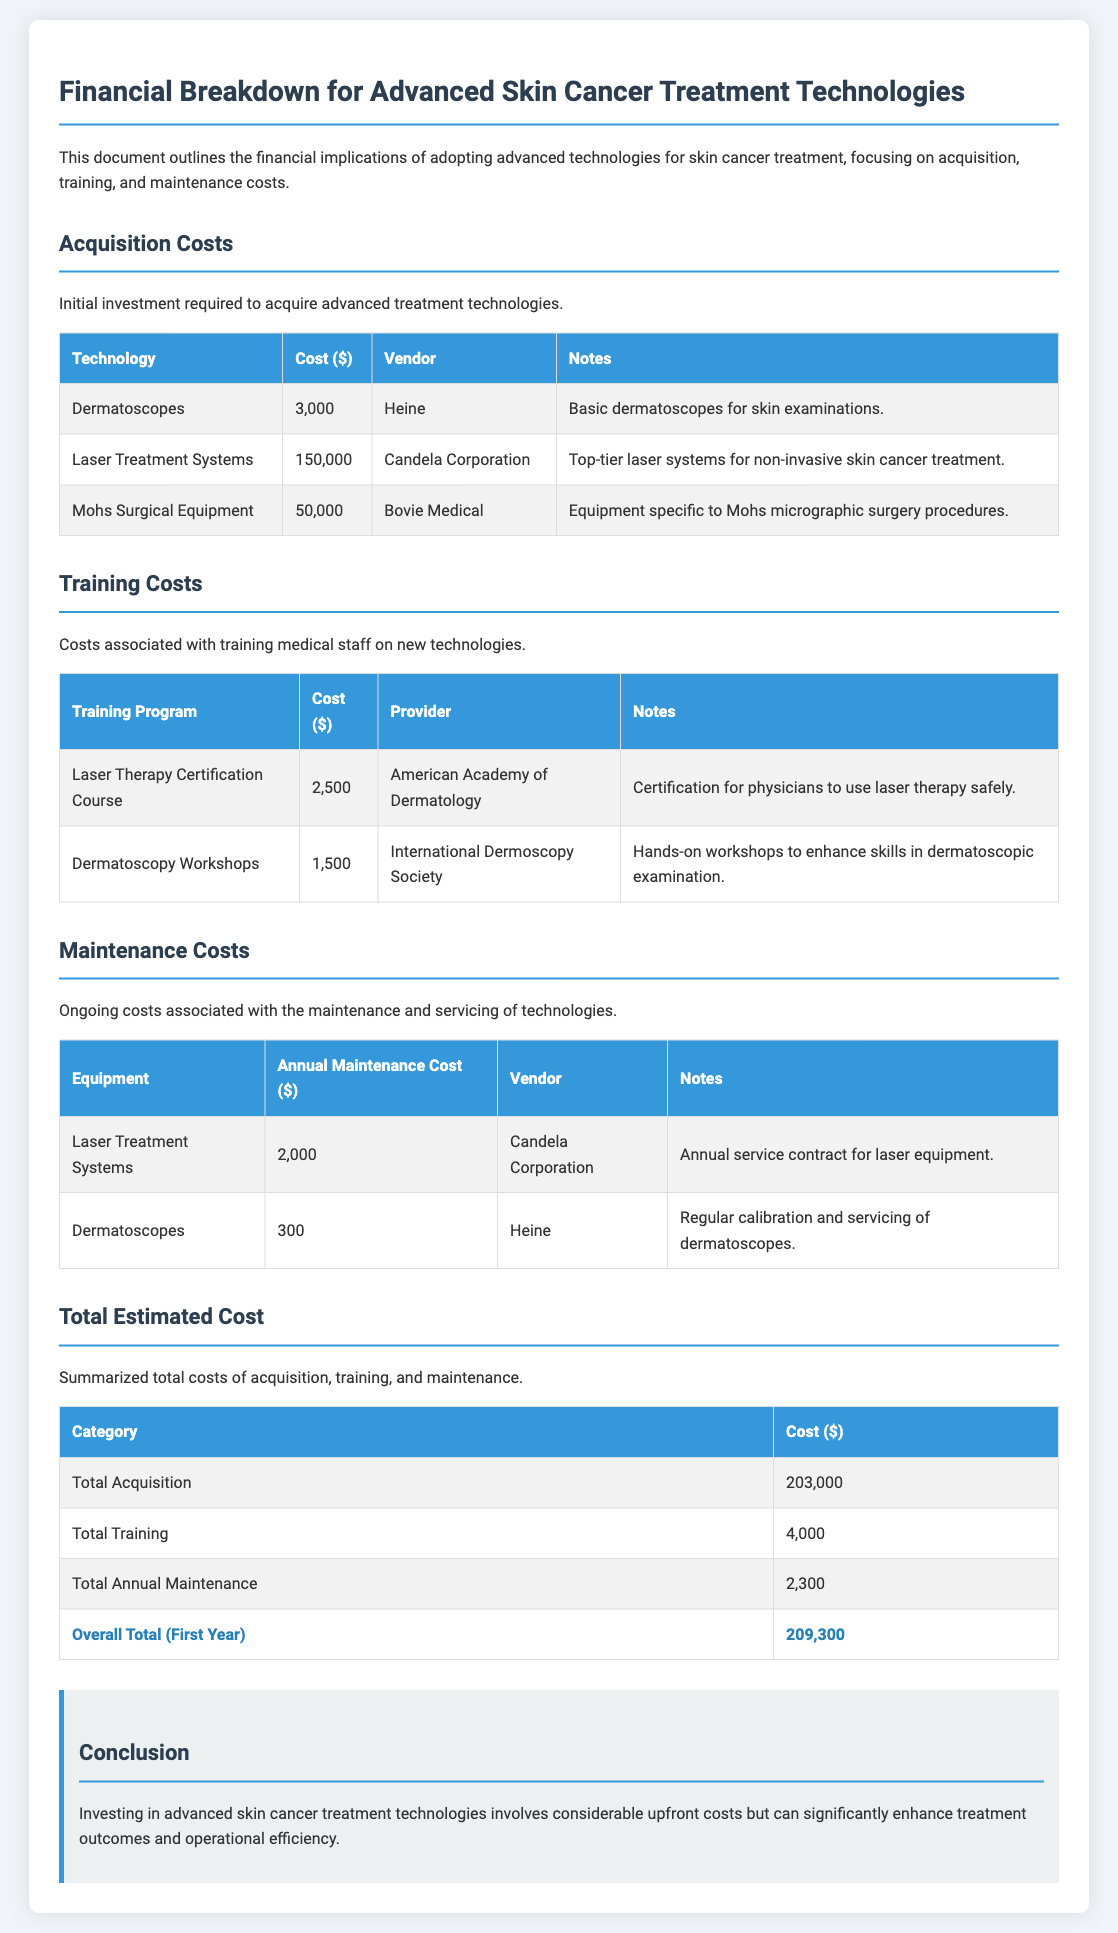What is the cost of Dermatoscopes? The cost of Dermatoscopes is specified in the acquisition costs table, which is $3,000.
Answer: $3,000 Who is the vendor for Laser Treatment Systems? The vendor for Laser Treatment Systems is indicated as Candela Corporation in the acquisition costs section.
Answer: Candela Corporation What is the total acquisition cost? The total acquisition cost is listed in the summarized total costs table, which amounts to $203,000.
Answer: $203,000 How much does the Laser Therapy Certification Course cost? The cost of the Laser Therapy Certification Course is highlighted in the training costs table as $2,500.
Answer: $2,500 What is the annual maintenance cost for Dermatoscopes? The annual maintenance cost for Dermatoscopes is mentioned in the maintenance costs section as $300.
Answer: $300 What is the overall total for the first year? The overall total for the first year is the sum of acquisition, training, and maintenance costs, which is stated as $209,300.
Answer: $209,300 Which training program has the highest cost? The training program with the highest cost is identified in the training costs table as the Laser Therapy Certification Course, costing $2,500.
Answer: Laser Therapy Certification Course What are the notes for Mohs Surgical Equipment? The notes for Mohs Surgical Equipment describe it as equipment specific to Mohs micrographic surgery procedures, as noted in the acquisition costs.
Answer: Equipment specific to Mohs micrographic surgery procedures What type of technology is listed for maintenance? The maintenance costs section lists types of technology which include Laser Treatment Systems and Dermatoscopes.
Answer: Laser Treatment Systems and Dermatoscopes 